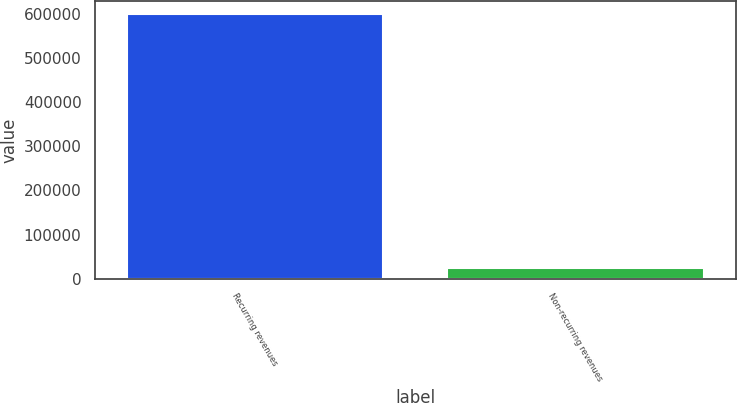<chart> <loc_0><loc_0><loc_500><loc_500><bar_chart><fcel>Recurring revenues<fcel>Non-recurring revenues<nl><fcel>598860<fcel>24355<nl></chart> 